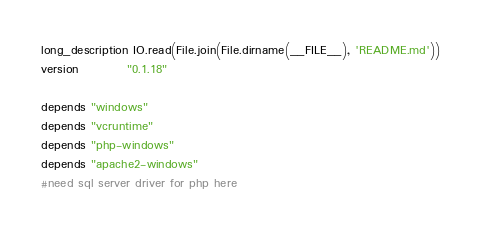Convert code to text. <code><loc_0><loc_0><loc_500><loc_500><_Ruby_>long_description IO.read(File.join(File.dirname(__FILE__), 'README.md'))
version          "0.1.18"

depends "windows" 
depends "vcruntime"
depends "php-windows"
depends "apache2-windows"
#need sql server driver for php here
</code> 